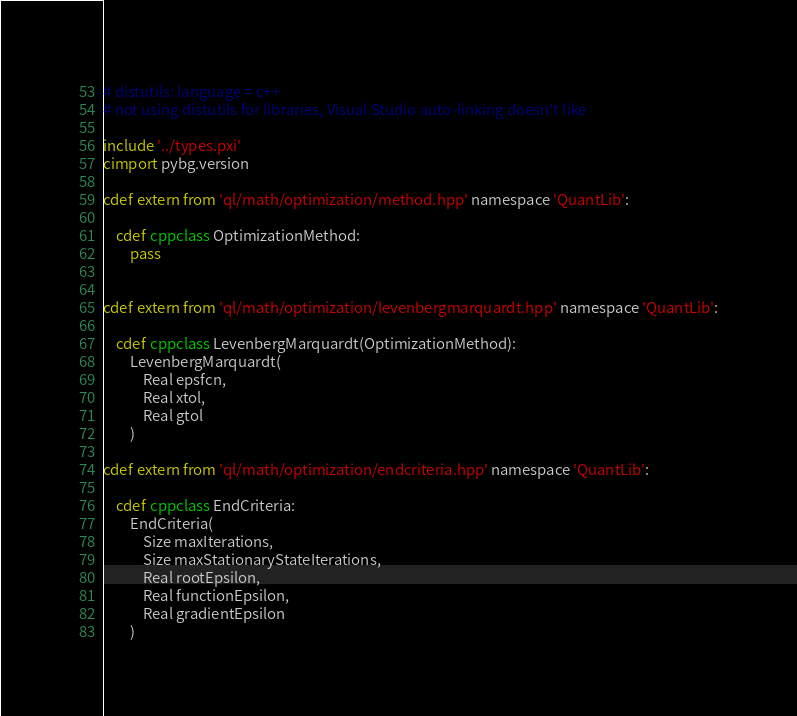Convert code to text. <code><loc_0><loc_0><loc_500><loc_500><_Cython_># distutils: language = c++
# not using distutils for libraries, Visual Studio auto-linking doesn't like

include '../types.pxi'
cimport pybg.version

cdef extern from 'ql/math/optimization/method.hpp' namespace 'QuantLib':

    cdef cppclass OptimizationMethod:
        pass


cdef extern from 'ql/math/optimization/levenbergmarquardt.hpp' namespace 'QuantLib':

    cdef cppclass LevenbergMarquardt(OptimizationMethod):
        LevenbergMarquardt(
            Real epsfcn,
            Real xtol,
            Real gtol
        )

cdef extern from 'ql/math/optimization/endcriteria.hpp' namespace 'QuantLib':

    cdef cppclass EndCriteria:
        EndCriteria(
            Size maxIterations,
            Size maxStationaryStateIterations,
            Real rootEpsilon,
            Real functionEpsilon,
            Real gradientEpsilon
        )
</code> 